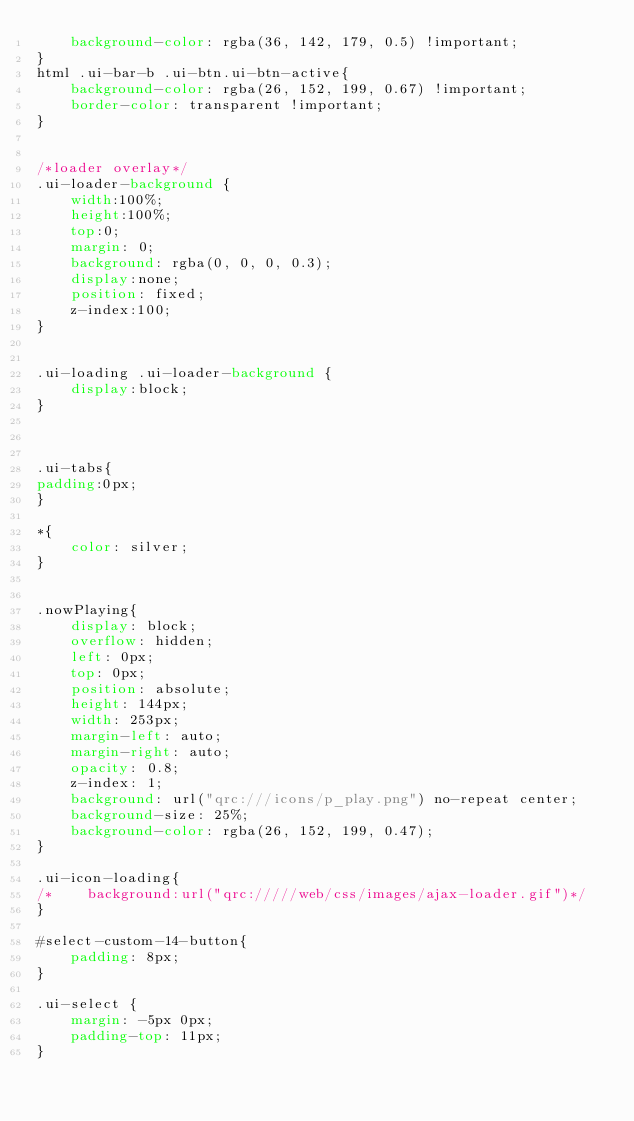<code> <loc_0><loc_0><loc_500><loc_500><_CSS_>    background-color: rgba(36, 142, 179, 0.5) !important;
}
html .ui-bar-b .ui-btn.ui-btn-active{
    background-color: rgba(26, 152, 199, 0.67) !important;
    border-color: transparent !important;
}


/*loader overlay*/
.ui-loader-background {
    width:100%;
    height:100%;
    top:0;
    margin: 0;
    background: rgba(0, 0, 0, 0.3);
    display:none;
    position: fixed;
    z-index:100;
}


.ui-loading .ui-loader-background {
    display:block;
}



.ui-tabs{
padding:0px;
}

*{
    color: silver;
}


.nowPlaying{
    display: block;
    overflow: hidden;
    left: 0px;
    top: 0px;
    position: absolute;
    height: 144px;
    width: 253px;
    margin-left: auto;
    margin-right: auto;
    opacity: 0.8;
    z-index: 1;
    background: url("qrc:///icons/p_play.png") no-repeat center;
    background-size: 25%;
    background-color: rgba(26, 152, 199, 0.47);
}

.ui-icon-loading{
/*    background:url("qrc://///web/css/images/ajax-loader.gif")*/
}

#select-custom-14-button{
    padding: 8px;
}

.ui-select {
    margin: -5px 0px;
    padding-top: 11px;
}
</code> 